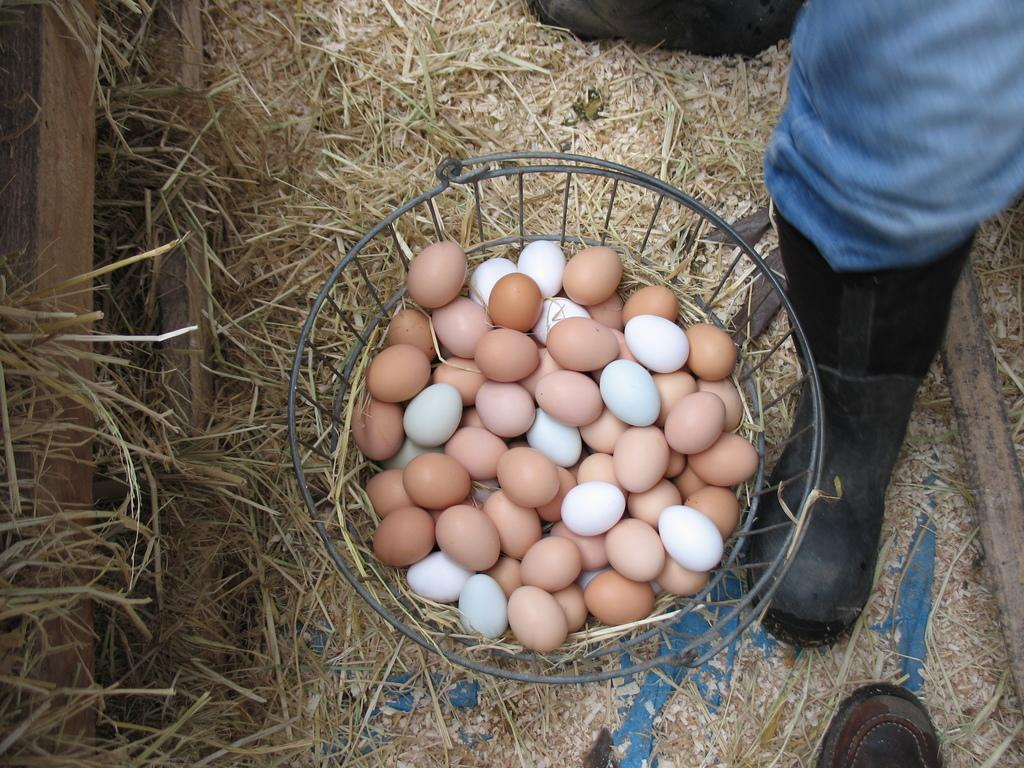What objects are present in the image? There are eggs in the image. How are the eggs arranged or contained? The eggs are in a basket. What can be seen in the background of the image? There is grass visible in the background of the image. What type of stem can be seen growing from the eggs in the image? There is no stem growing from the eggs in the image; they are simply contained in a basket. 